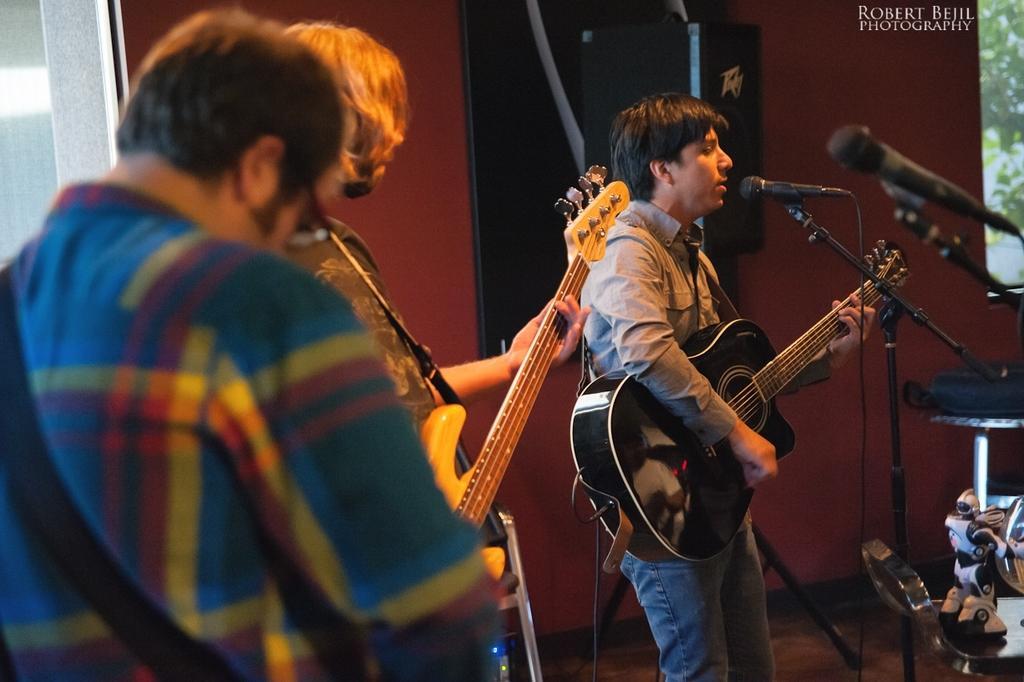Describe this image in one or two sentences. In this picture we can see three persons standing on the floor. This is mike and they are playing guitars. On the background there is a red color wall. And this is the screen. 